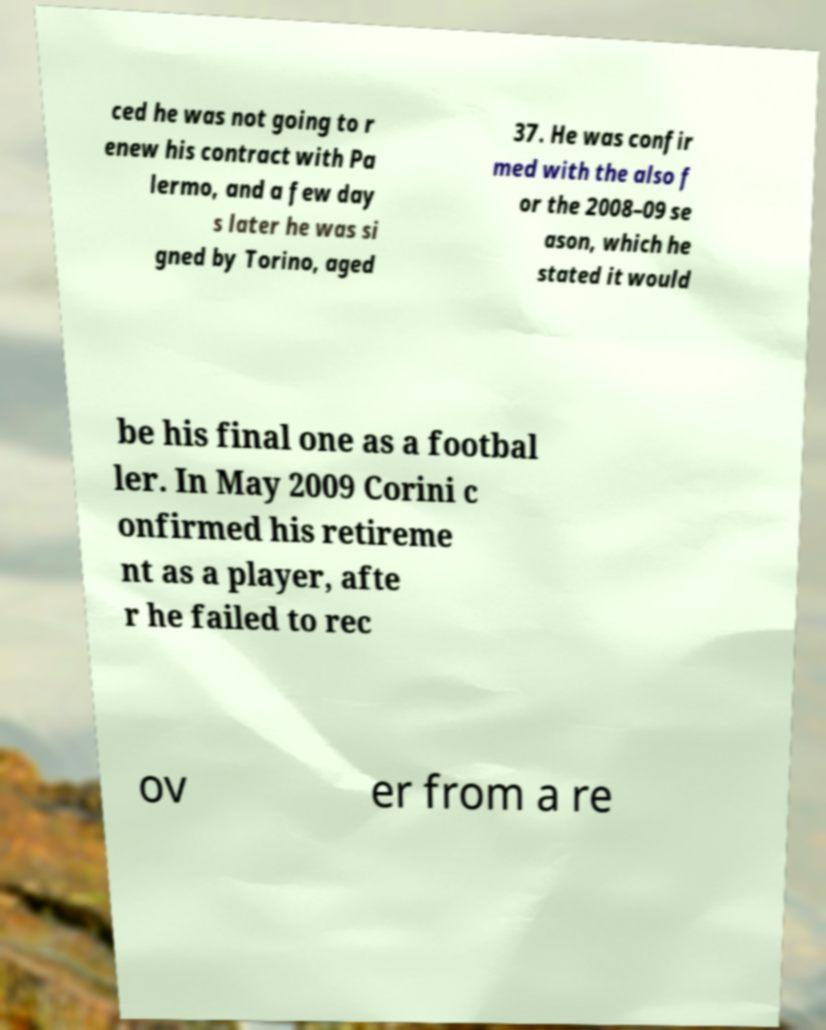What messages or text are displayed in this image? I need them in a readable, typed format. ced he was not going to r enew his contract with Pa lermo, and a few day s later he was si gned by Torino, aged 37. He was confir med with the also f or the 2008–09 se ason, which he stated it would be his final one as a footbal ler. In May 2009 Corini c onfirmed his retireme nt as a player, afte r he failed to rec ov er from a re 